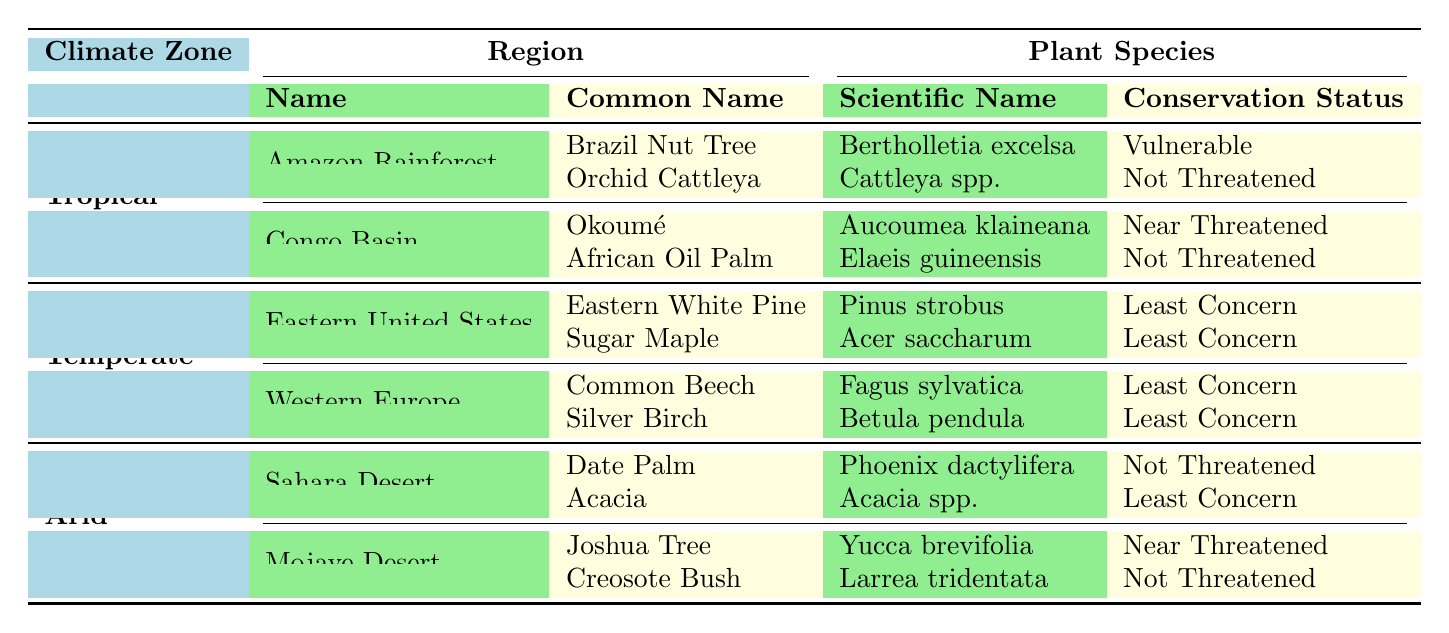What is the conservation status of the Brazil Nut Tree? The Brazil Nut Tree is listed under the plant species found in the Amazon Rainforest, and its conservation status, as indicated in the table, is Vulnerable.
Answer: Vulnerable How many plant species are listed for the Congo Basin? The Congo Basin has two plant species listed: Okoumé and African Oil Palm. Therefore, the total count is 2.
Answer: 2 Is the Sugar Maple endemic or non-endemic? According to the table, the Sugar Maple is categorized as non-endemic as stated next to its scientific name.
Answer: Non-endemic Which climate zone has the highest number of endemic species? The Tropical climate zone demonstrates the highest number of endemic species, with both Brazil Nut Tree and Okoumé listed as endemic. Thus, it has a total of 2 endemic species.
Answer: Tropical What is the scientific name of the Joshua Tree? The scientific name for the Joshua Tree, as indicated in the Mojave Desert region of the table, is Yucca brevifolia.
Answer: Yucca brevifolia Are there any threatened plant species listed in the Temperate climate zone? The table shows that all plant species in the Temperate climate zone have a conservation status of Least Concern, meaning there are no threatened species listed in this zone.
Answer: No How do the conservation statuses compare between the plant species in the Sahara Desert and Mojave Desert? In the Sahara Desert, the Date Palm has a status of Not Threatened, while the Acacia is Least Concern. In the Mojave Desert, the Joshua Tree is Near Threatened, and the Creosote Bush is Not Threatened. This shows variability in statuses, with one Near Threatened in the Mojave Desert.
Answer: Variable statuses Which plant species is endemic in Western Europe? The Common Beech is the only endemic plant species listed in the Western Europe region, as noted in the table.
Answer: Common Beech How many plant species in the Tropical climate zone are classified as non-endemic? In the Tropical climate zone, the table lists one non-endemic species: the Orchid Cattleya. Therefore, there is a total of one non-endemic species.
Answer: 1 What is the overall total number of plant species listed in the table? The table has a total of 12 plant species (2 in Amazon, 2 in Congo, 4 in Eastern US, 2 in Western Europe, 2 in Sahara, and 2 in Mojave), summing up to 12.
Answer: 12 